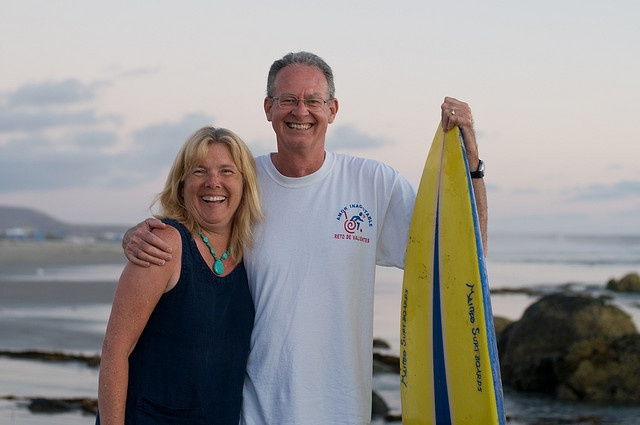Describe the objects in this image and their specific colors. I can see people in lightgray, darkgray, brown, and gray tones, people in lightgray, black, and brown tones, and surfboard in lightgray, olive, navy, and gray tones in this image. 